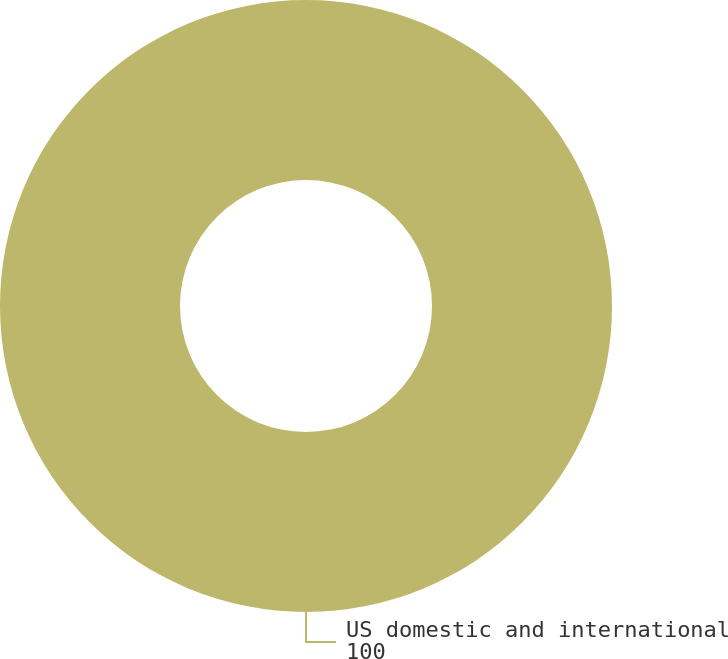<chart> <loc_0><loc_0><loc_500><loc_500><pie_chart><fcel>US domestic and international<nl><fcel>100.0%<nl></chart> 